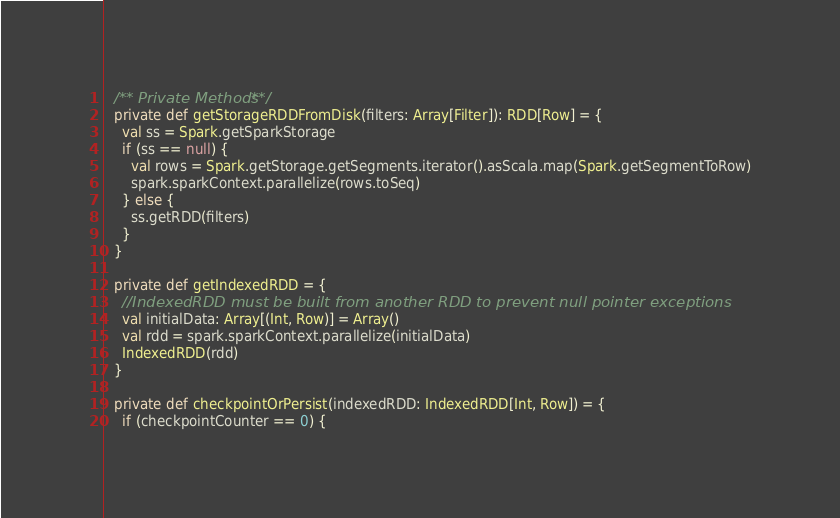<code> <loc_0><loc_0><loc_500><loc_500><_Scala_>
  /** Private Methods **/
  private def getStorageRDDFromDisk(filters: Array[Filter]): RDD[Row] = {
    val ss = Spark.getSparkStorage
    if (ss == null) {
      val rows = Spark.getStorage.getSegments.iterator().asScala.map(Spark.getSegmentToRow)
      spark.sparkContext.parallelize(rows.toSeq)
    } else {
      ss.getRDD(filters)
    }
  }

  private def getIndexedRDD = {
    //IndexedRDD must be built from another RDD to prevent null pointer exceptions
    val initialData: Array[(Int, Row)] = Array()
    val rdd = spark.sparkContext.parallelize(initialData)
    IndexedRDD(rdd)
  }

  private def checkpointOrPersist(indexedRDD: IndexedRDD[Int, Row]) = {
    if (checkpointCounter == 0) {</code> 